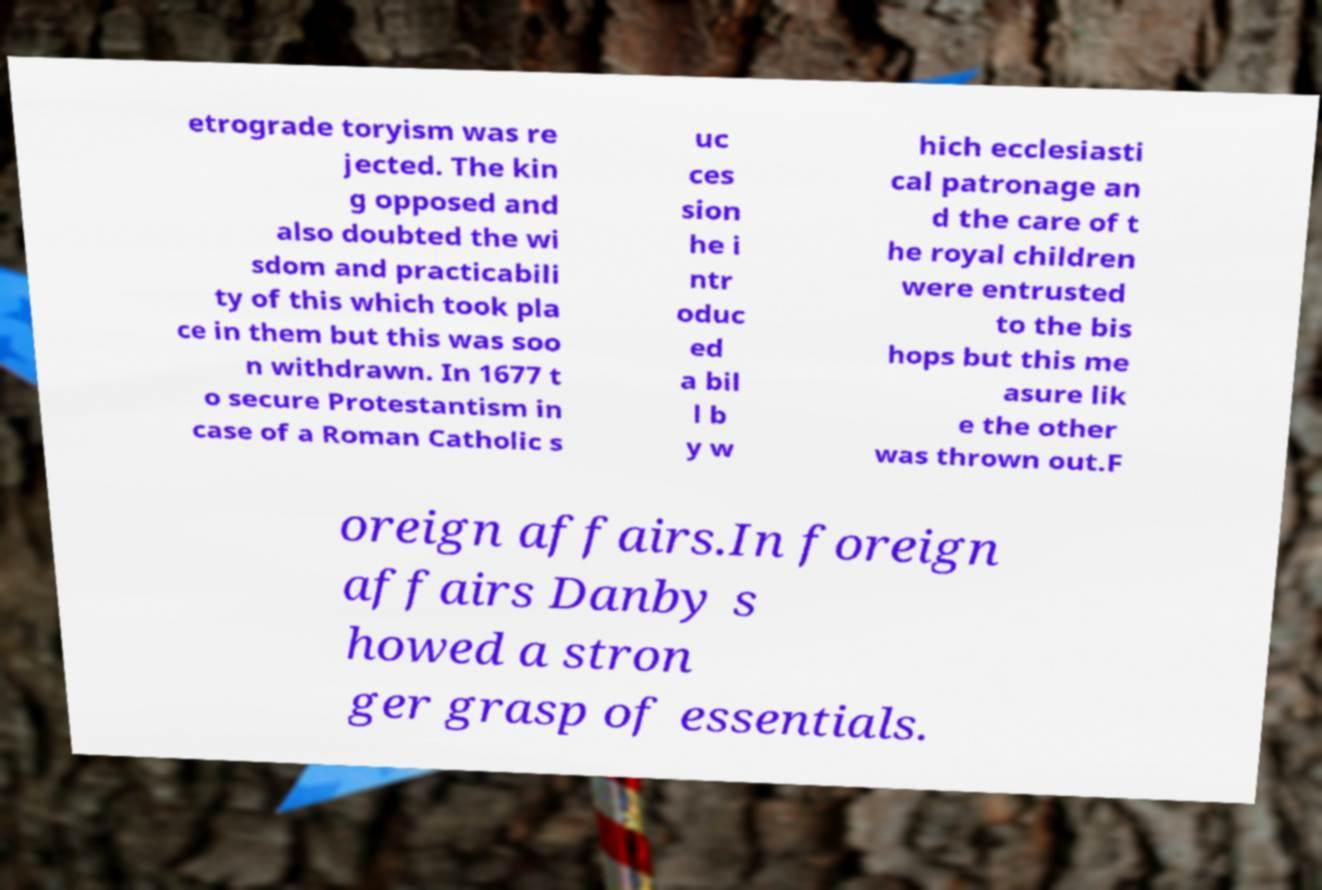There's text embedded in this image that I need extracted. Can you transcribe it verbatim? etrograde toryism was re jected. The kin g opposed and also doubted the wi sdom and practicabili ty of this which took pla ce in them but this was soo n withdrawn. In 1677 t o secure Protestantism in case of a Roman Catholic s uc ces sion he i ntr oduc ed a bil l b y w hich ecclesiasti cal patronage an d the care of t he royal children were entrusted to the bis hops but this me asure lik e the other was thrown out.F oreign affairs.In foreign affairs Danby s howed a stron ger grasp of essentials. 